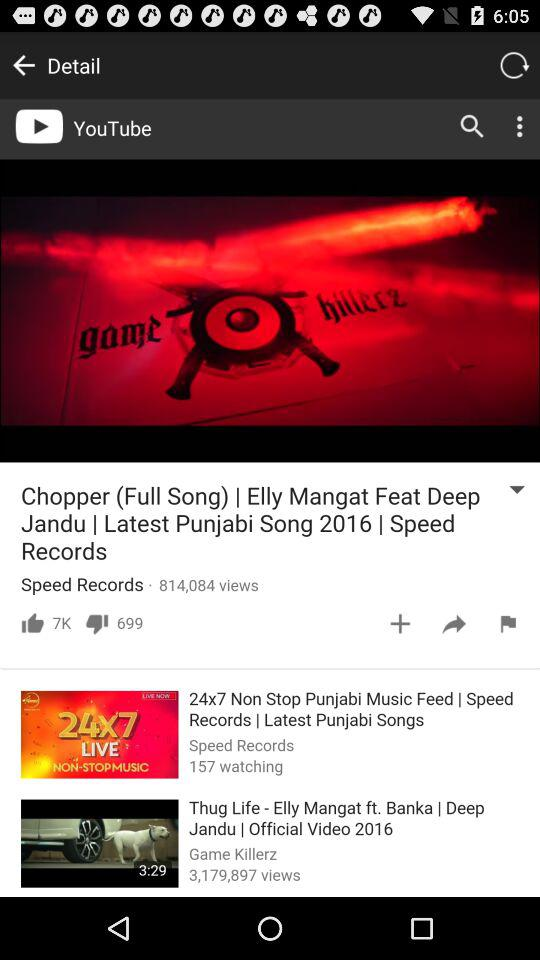How many likes and dislikes are there of "Chopper (Full Song)"? There are 7K likes and 699 dislikes of "Chopper (Full Song)". 